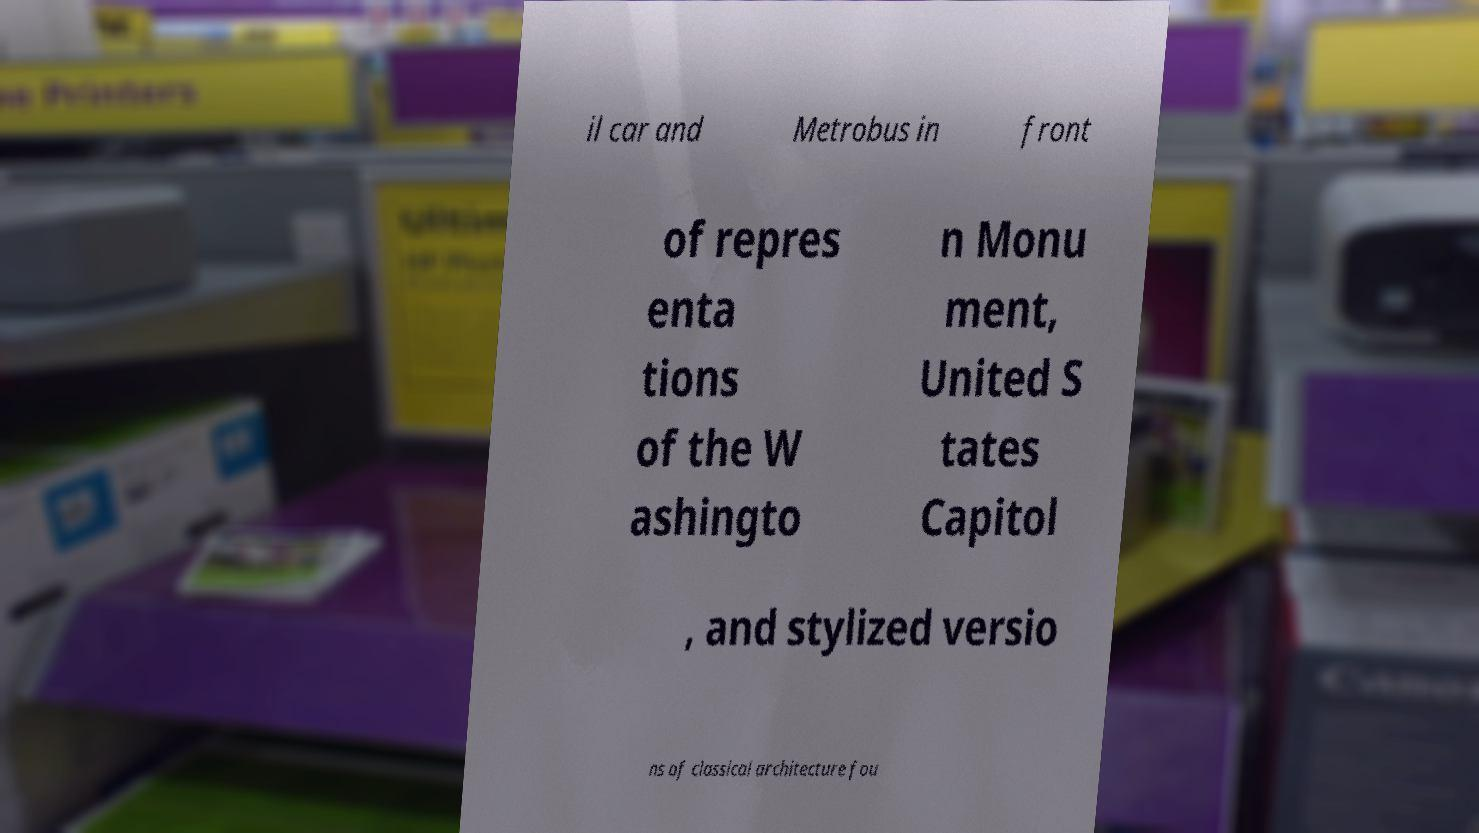Could you assist in decoding the text presented in this image and type it out clearly? il car and Metrobus in front of repres enta tions of the W ashingto n Monu ment, United S tates Capitol , and stylized versio ns of classical architecture fou 